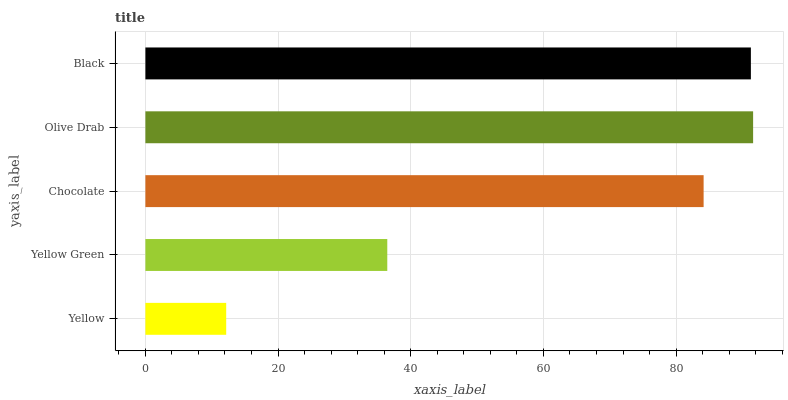Is Yellow the minimum?
Answer yes or no. Yes. Is Olive Drab the maximum?
Answer yes or no. Yes. Is Yellow Green the minimum?
Answer yes or no. No. Is Yellow Green the maximum?
Answer yes or no. No. Is Yellow Green greater than Yellow?
Answer yes or no. Yes. Is Yellow less than Yellow Green?
Answer yes or no. Yes. Is Yellow greater than Yellow Green?
Answer yes or no. No. Is Yellow Green less than Yellow?
Answer yes or no. No. Is Chocolate the high median?
Answer yes or no. Yes. Is Chocolate the low median?
Answer yes or no. Yes. Is Olive Drab the high median?
Answer yes or no. No. Is Yellow the low median?
Answer yes or no. No. 